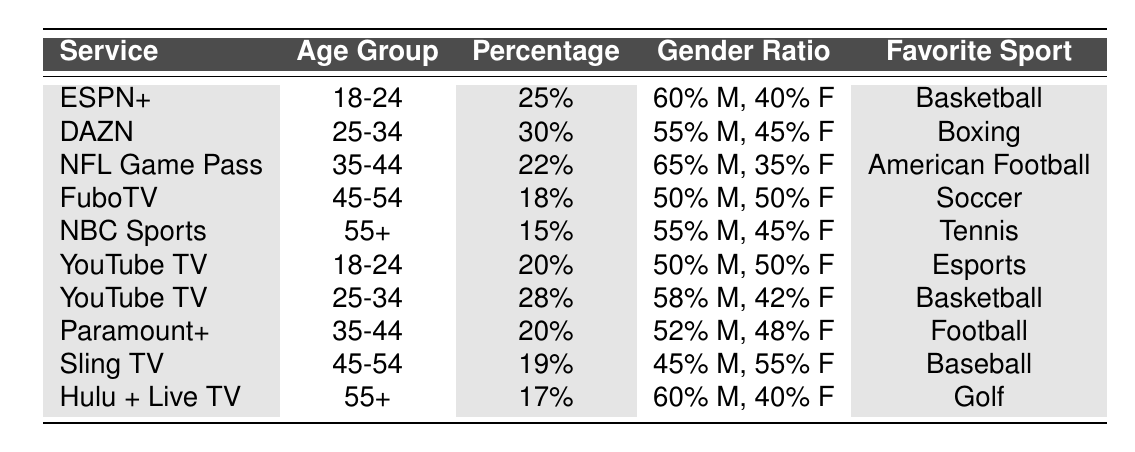What's the favorite sport for the age group 18-24 on ESPN+? The table shows that for ESPN+, the favorite sport in the 18-24 age group is listed as Basketball.
Answer: Basketball What percentage of viewers for DAZN are aged 25-34? The table states that DAZN has a viewership percentage of 30% in the 25-34 age group.
Answer: 30% Which service has the highest percentage of viewership in the 35-44 age group? By comparing the percentage values, NFL Game Pass has the highest viewership at 22% in the 35-44 age group.
Answer: NFL Game Pass Is there a service that has a 50% gender ratio among its viewers? Yes, FuboTV has a 50% male and 50% female gender ratio in the 45-54 age group.
Answer: Yes What is the overall percentage of viewers aged 55 and above for all services listed? The percentages for the 55+ age group are 15% for NBC Sports and 17% for Hulu + Live TV, combining these gives a total of 32%.
Answer: 32% Which service is favored by the highest percentage of female viewers in the 45-54 age group? In the 45-54 age group, Sling TV has the highest percentage of female viewers at 55%.
Answer: Sling TV What is the median percentage of viewership across all age groups listed in YouTube TV? For YouTube TV, the percentages listed are 20% and 28%. The median, being the middle value when sorted (20%, 28%), is 24%.
Answer: 24% Which age group has the lowest average percentage of viewership among the services? The average percentages for each age group are: 18-24 (22.5%), 25-34 (29%), 35-44 (21%), 45-54 (18.5%), 55+ (16%). The lowest average is from the 55+ age group.
Answer: 55+ Are more viewers aged 18-24 on ESPN+ or YouTube TV? ESPN+ has 25% and YouTube TV has 20% in the 18-24 age group, thus more viewers are on ESPN+.
Answer: ESPN+ What is the favorite sport of viewers aged 45-54 for FuboTV? According to the table, the favorite sport for viewers aged 45-54 using FuboTV is Soccer.
Answer: Soccer 